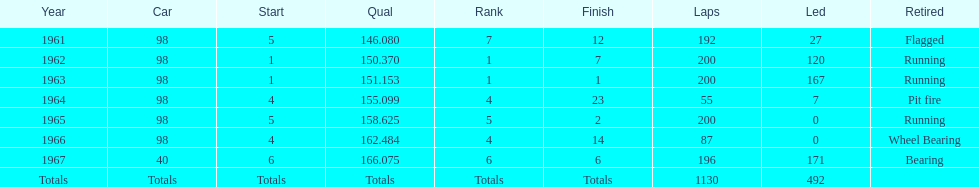During which years did he lead the race the fewest times? 1965, 1966. 